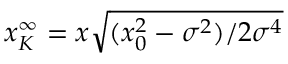<formula> <loc_0><loc_0><loc_500><loc_500>x _ { K } ^ { \infty } = x \sqrt { ( x _ { 0 } ^ { 2 } - \sigma ^ { 2 } ) / 2 \sigma ^ { 4 } }</formula> 